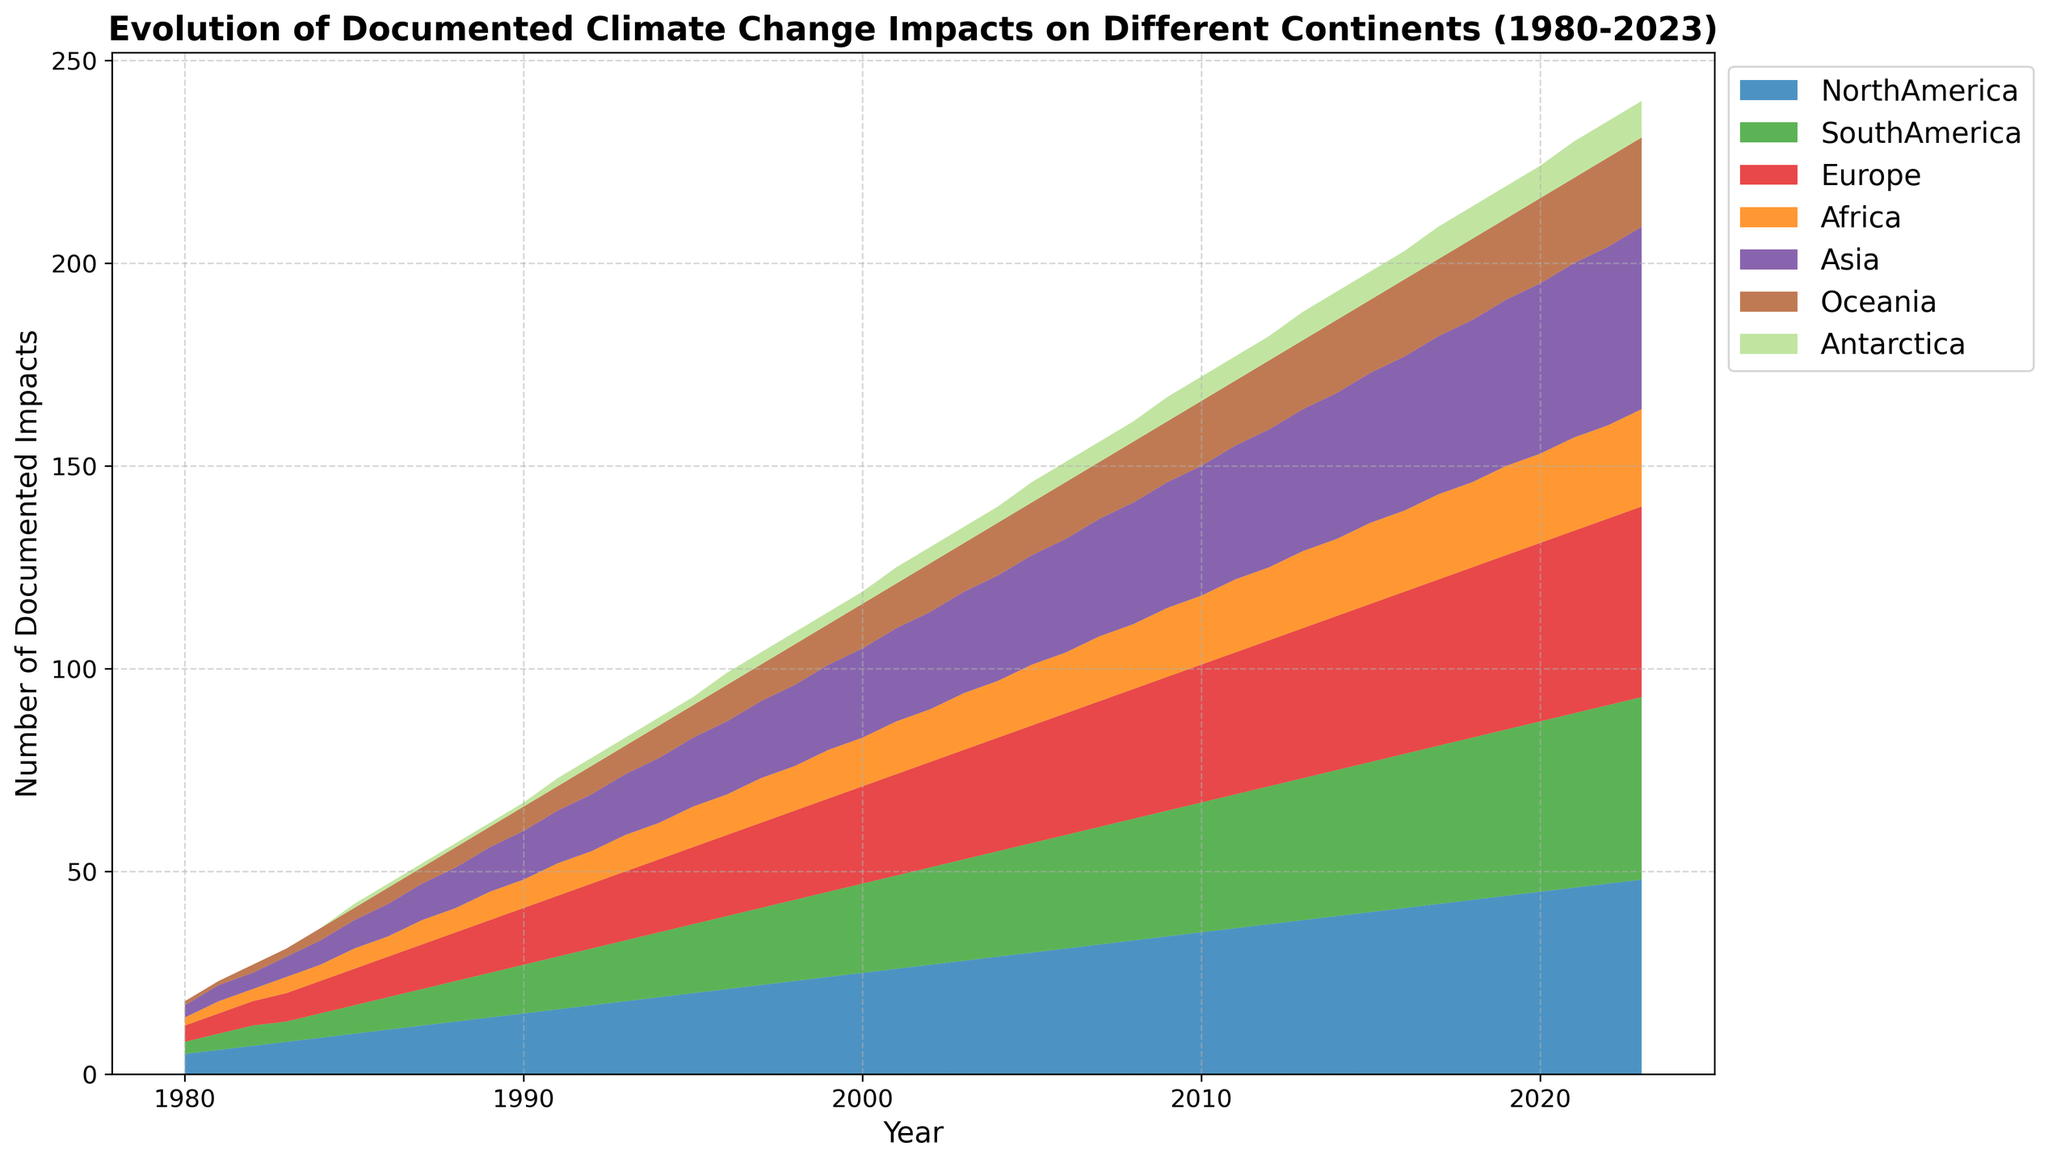What year did North America reach 40 documented impacts? To find the year North America reached 40 documented impacts, locate the area representing North America in the chart. Follow its growth trajectory to where it reaches the 40 impacts mark.
Answer: 2015 Which continent showed the least number of impacts throughout the entire period? Identify the continent with the smallest area under the curve from 1980 to 2023. In this case, Antarctica consistently shows the smallest values, remaining mostly near zero.
Answer: Antarctica Which continent had a steady increase in documented impacts from 1980 to 2023 without reduction in any year? Check the areas under the curves for each continent from 1980 to 2023. North America shows a consistent increase every year without any reduction.
Answer: North America In which year did Europe reach 30 documented impacts? Locate the area representing Europe in the chart and track its rise over the years to where it intersects the 30 impacts mark.
Answer: 2007 By how much did the number of documented impacts in Asia increase from 1990 to 2020? From the chart, find the number of documented impacts in Asia for 1990 (12) and 2020 (42). Then, calculate the difference: 42 - 12.
Answer: 30 Which two continents had the closest number of documented impacts in 1995? Extract the documented impacts for each continent in 1995 from the chart. Compare them and identify which two continents have the smallest difference: South America (17) and Oceania (8).
Answer: South America and Oceania How many documented impacts in total are shown across all continents in 2000? Sum documented impacts for each continent in the year 2000 from the chart: 25 (North America) + 22 (South America) + 24 (Europe) + 12 (Africa) + 22 (Asia) + 11 (Oceania) + 3 (Antarctica) = 119.
Answer: 119 Between which two contiguous decades did Africa see the largest increase in documented impacts? Calculate the increase in documented impacts for Africa over each decade: 1980 (2) – 1990 (7), 1990 (7) – 2000 (12), and 2000 (12) – 2010 (17). Africa’s largest increase (5) is between 1990 and 2000.
Answer: 1990 to 2000 